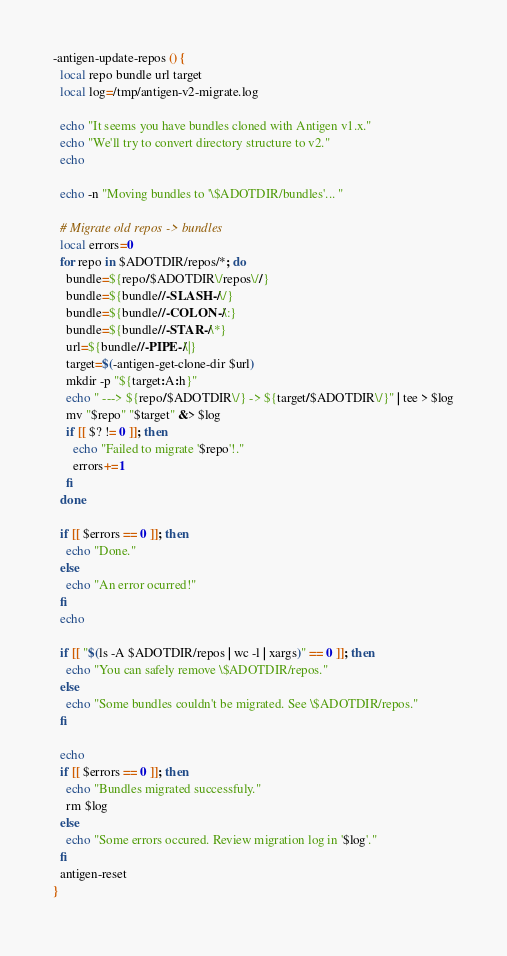<code> <loc_0><loc_0><loc_500><loc_500><_Bash_>-antigen-update-repos () {
  local repo bundle url target
  local log=/tmp/antigen-v2-migrate.log

  echo "It seems you have bundles cloned with Antigen v1.x."
  echo "We'll try to convert directory structure to v2."
  echo

  echo -n "Moving bundles to '\$ADOTDIR/bundles'... "

  # Migrate old repos -> bundles
  local errors=0
  for repo in $ADOTDIR/repos/*; do
    bundle=${repo/$ADOTDIR\/repos\//}
    bundle=${bundle//-SLASH-/\/}
    bundle=${bundle//-COLON-/\:}
    bundle=${bundle//-STAR-/\*}
    url=${bundle//-PIPE-/\|}
    target=$(-antigen-get-clone-dir $url)
    mkdir -p "${target:A:h}"
    echo " ---> ${repo/$ADOTDIR\/} -> ${target/$ADOTDIR\/}" | tee > $log
    mv "$repo" "$target" &> $log
    if [[ $? != 0 ]]; then
      echo "Failed to migrate '$repo'!."
      errors+=1
    fi
  done

  if [[ $errors == 0 ]]; then
    echo "Done."
  else
    echo "An error ocurred!"
  fi
  echo

  if [[ "$(ls -A $ADOTDIR/repos | wc -l | xargs)" == 0 ]]; then
    echo "You can safely remove \$ADOTDIR/repos."
  else
    echo "Some bundles couldn't be migrated. See \$ADOTDIR/repos."
  fi

  echo
  if [[ $errors == 0 ]]; then
    echo "Bundles migrated successfuly."
    rm $log
  else
    echo "Some errors occured. Review migration log in '$log'."
  fi
  antigen-reset
}
</code> 